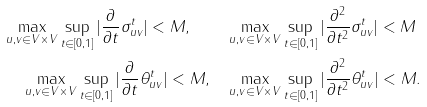<formula> <loc_0><loc_0><loc_500><loc_500>\max _ { u , v \in V \times V } \sup _ { t \in [ 0 , 1 ] } | \frac { \partial } { \partial t } \sigma _ { u v } ^ { t } | < M , \quad & \max _ { u , v \in V \times V } \sup _ { t \in [ 0 , 1 ] } | \frac { \partial ^ { 2 } } { \partial t ^ { 2 } } \sigma _ { u v } ^ { t } | < M \\ \max _ { u , v \in V \times V } \sup _ { t \in [ 0 , 1 ] } | \frac { \partial } { \partial t } \theta _ { u v } ^ { t } | < M , \quad & \max _ { u , v \in V \times V } \sup _ { t \in [ 0 , 1 ] } | \frac { \partial ^ { 2 } } { \partial t ^ { 2 } } \theta _ { u v } ^ { t } | < M .</formula> 